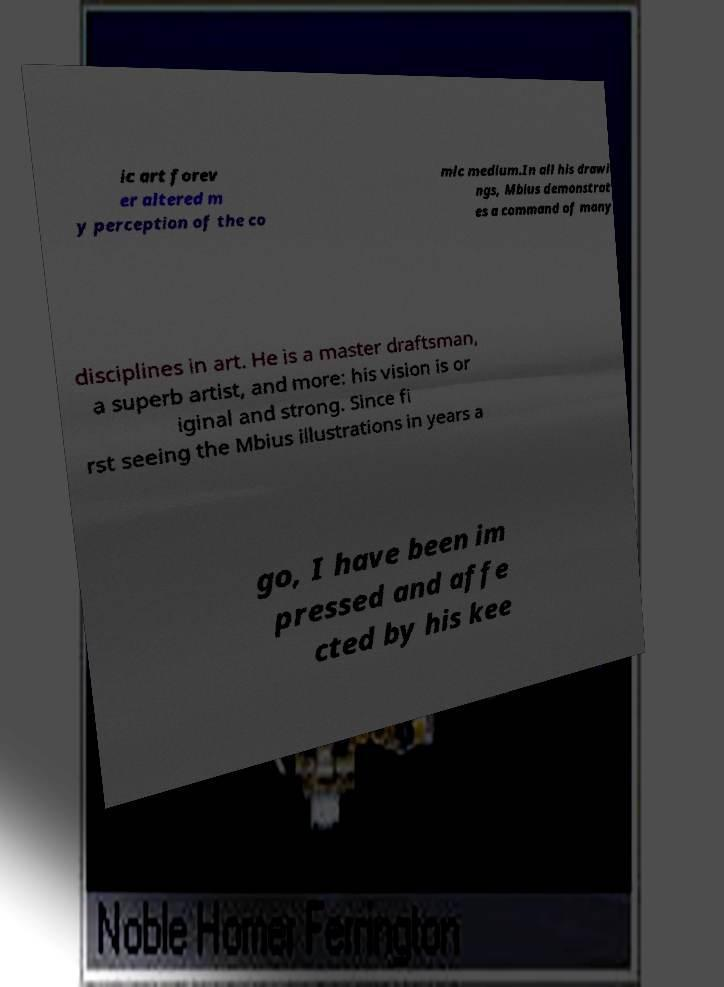Could you extract and type out the text from this image? ic art forev er altered m y perception of the co mic medium.In all his drawi ngs, Mbius demonstrat es a command of many disciplines in art. He is a master draftsman, a superb artist, and more: his vision is or iginal and strong. Since fi rst seeing the Mbius illustrations in years a go, I have been im pressed and affe cted by his kee 